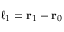<formula> <loc_0><loc_0><loc_500><loc_500>\ell _ { 1 } = r _ { 1 } - r _ { 0 }</formula> 